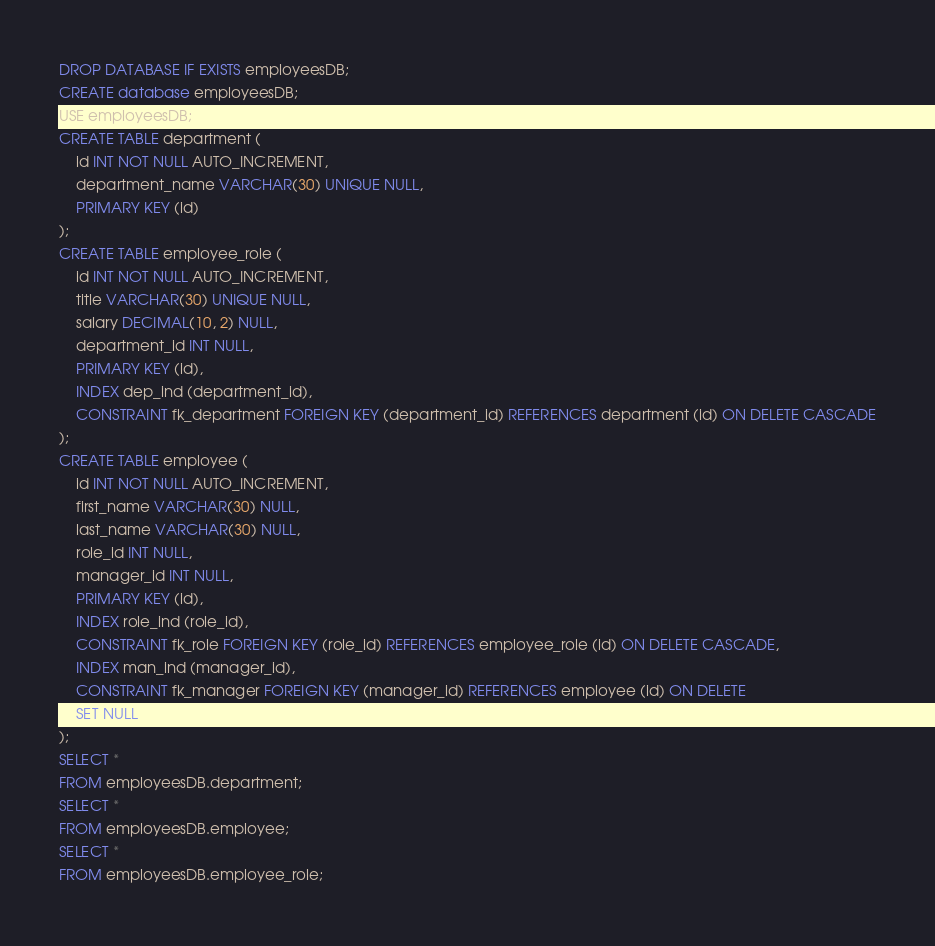Convert code to text. <code><loc_0><loc_0><loc_500><loc_500><_SQL_>DROP DATABASE IF EXISTS employeesDB;
CREATE database employeesDB;
USE employeesDB;
CREATE TABLE department (
    id INT NOT NULL AUTO_INCREMENT,
    department_name VARCHAR(30) UNIQUE NULL,
    PRIMARY KEY (id)
);
CREATE TABLE employee_role (
    id INT NOT NULL AUTO_INCREMENT,
    title VARCHAR(30) UNIQUE NULL,
    salary DECIMAL(10, 2) NULL,
    department_id INT NULL,
    PRIMARY KEY (id),
    INDEX dep_ind (department_id),
    CONSTRAINT fk_department FOREIGN KEY (department_id) REFERENCES department (id) ON DELETE CASCADE
);
CREATE TABLE employee (
    id INT NOT NULL AUTO_INCREMENT,
    first_name VARCHAR(30) NULL,
    last_name VARCHAR(30) NULL,
    role_id INT NULL,
    manager_id INT NULL,
    PRIMARY KEY (id),
    INDEX role_ind (role_id),
    CONSTRAINT fk_role FOREIGN KEY (role_id) REFERENCES employee_role (id) ON DELETE CASCADE,
    INDEX man_ind (manager_id),
    CONSTRAINT fk_manager FOREIGN KEY (manager_id) REFERENCES employee (id) ON DELETE
    SET NULL
);
SELECT *
FROM employeesDB.department;
SELECT *
FROM employeesDB.employee;
SELECT *
FROM employeesDB.employee_role;</code> 